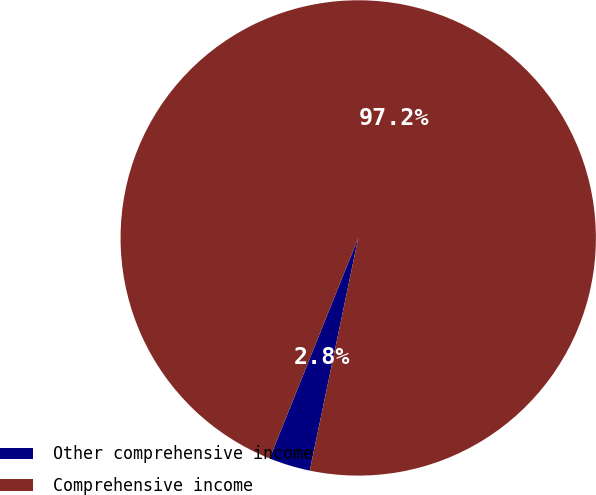Convert chart to OTSL. <chart><loc_0><loc_0><loc_500><loc_500><pie_chart><fcel>Other comprehensive income<fcel>Comprehensive income<nl><fcel>2.81%<fcel>97.19%<nl></chart> 